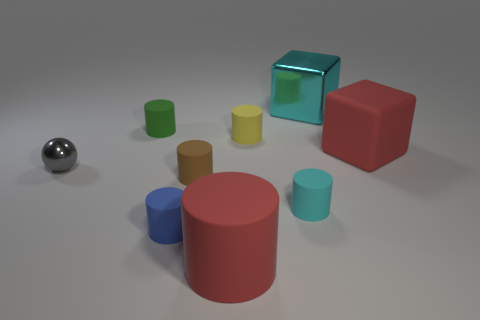What material is the brown cylinder that is the same size as the cyan cylinder?
Offer a very short reply. Rubber. What material is the large cylinder?
Ensure brevity in your answer.  Rubber. Are there any other things that are the same shape as the small cyan rubber thing?
Offer a terse response. Yes. The small metal thing is what shape?
Ensure brevity in your answer.  Sphere. Does the big object in front of the big red rubber block have the same shape as the small shiny thing?
Ensure brevity in your answer.  No. Is the number of small matte cylinders that are on the left side of the yellow cylinder greater than the number of small rubber cylinders right of the cyan cube?
Your answer should be very brief. Yes. How many other objects are there of the same size as the sphere?
Provide a succinct answer. 5. There is a tiny brown matte object; is its shape the same as the big rubber object that is in front of the tiny gray ball?
Offer a very short reply. Yes. What number of metal things are large blue blocks or blue cylinders?
Provide a succinct answer. 0. Is there a cylinder of the same color as the matte block?
Offer a terse response. Yes. 